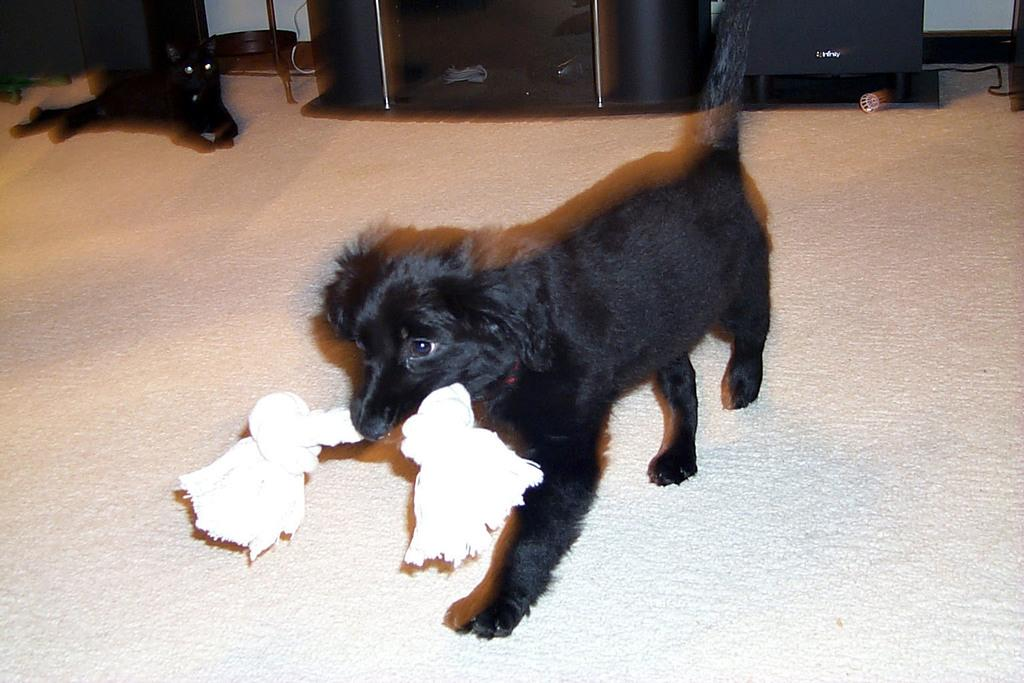What animal is holding an item in the image? There is a dog in the image holding an item. What other animal is present in the image? There is a cat in the image. What type of flooring is visible in the image? There is a carpet in the image. What type of furniture is present in the image? There is a cupboard in the image. Can you describe any other items present in the image? There are other items present in the image, but their specific nature is not mentioned in the provided facts. What type of flag is visible in the image? There is no flag present in the image. Can you describe the baseball bat in the image? There is no baseball bat present in the image. 